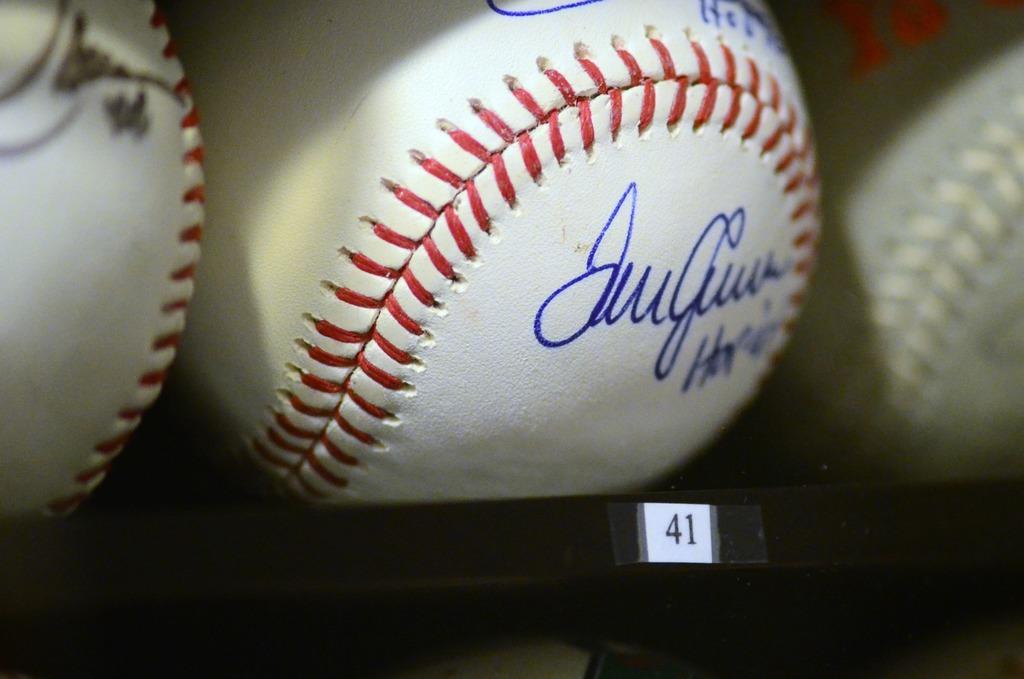What is the number underneath this baseball?
Offer a terse response. 41. 